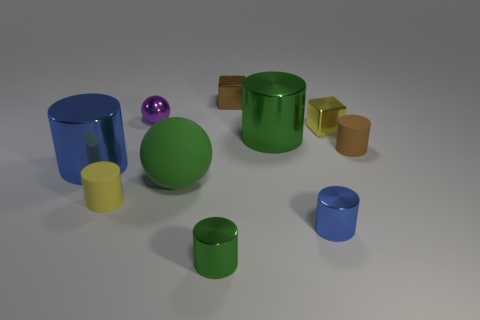Subtract all tiny yellow cylinders. How many cylinders are left? 5 Subtract all blue cubes. How many green cylinders are left? 2 Subtract all green cylinders. How many cylinders are left? 4 Subtract all blocks. How many objects are left? 8 Subtract all purple balls. Subtract all cyan cubes. How many balls are left? 1 Subtract all large brown metal things. Subtract all large balls. How many objects are left? 9 Add 5 purple spheres. How many purple spheres are left? 6 Add 7 tiny yellow matte cylinders. How many tiny yellow matte cylinders exist? 8 Subtract 0 green blocks. How many objects are left? 10 